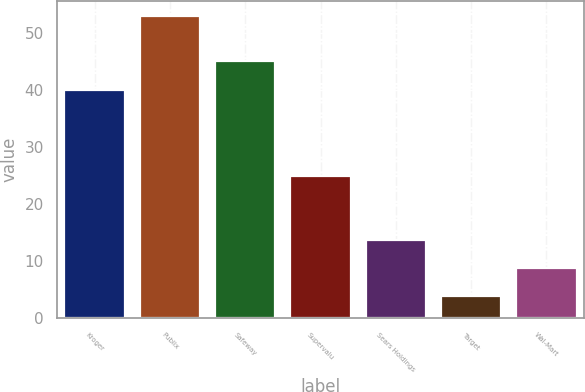Convert chart. <chart><loc_0><loc_0><loc_500><loc_500><bar_chart><fcel>Kroger<fcel>Publix<fcel>Safeway<fcel>Supervalu<fcel>Sears Holdings<fcel>Target<fcel>Wal-Mart<nl><fcel>40<fcel>53<fcel>45<fcel>25<fcel>13.8<fcel>4<fcel>8.9<nl></chart> 